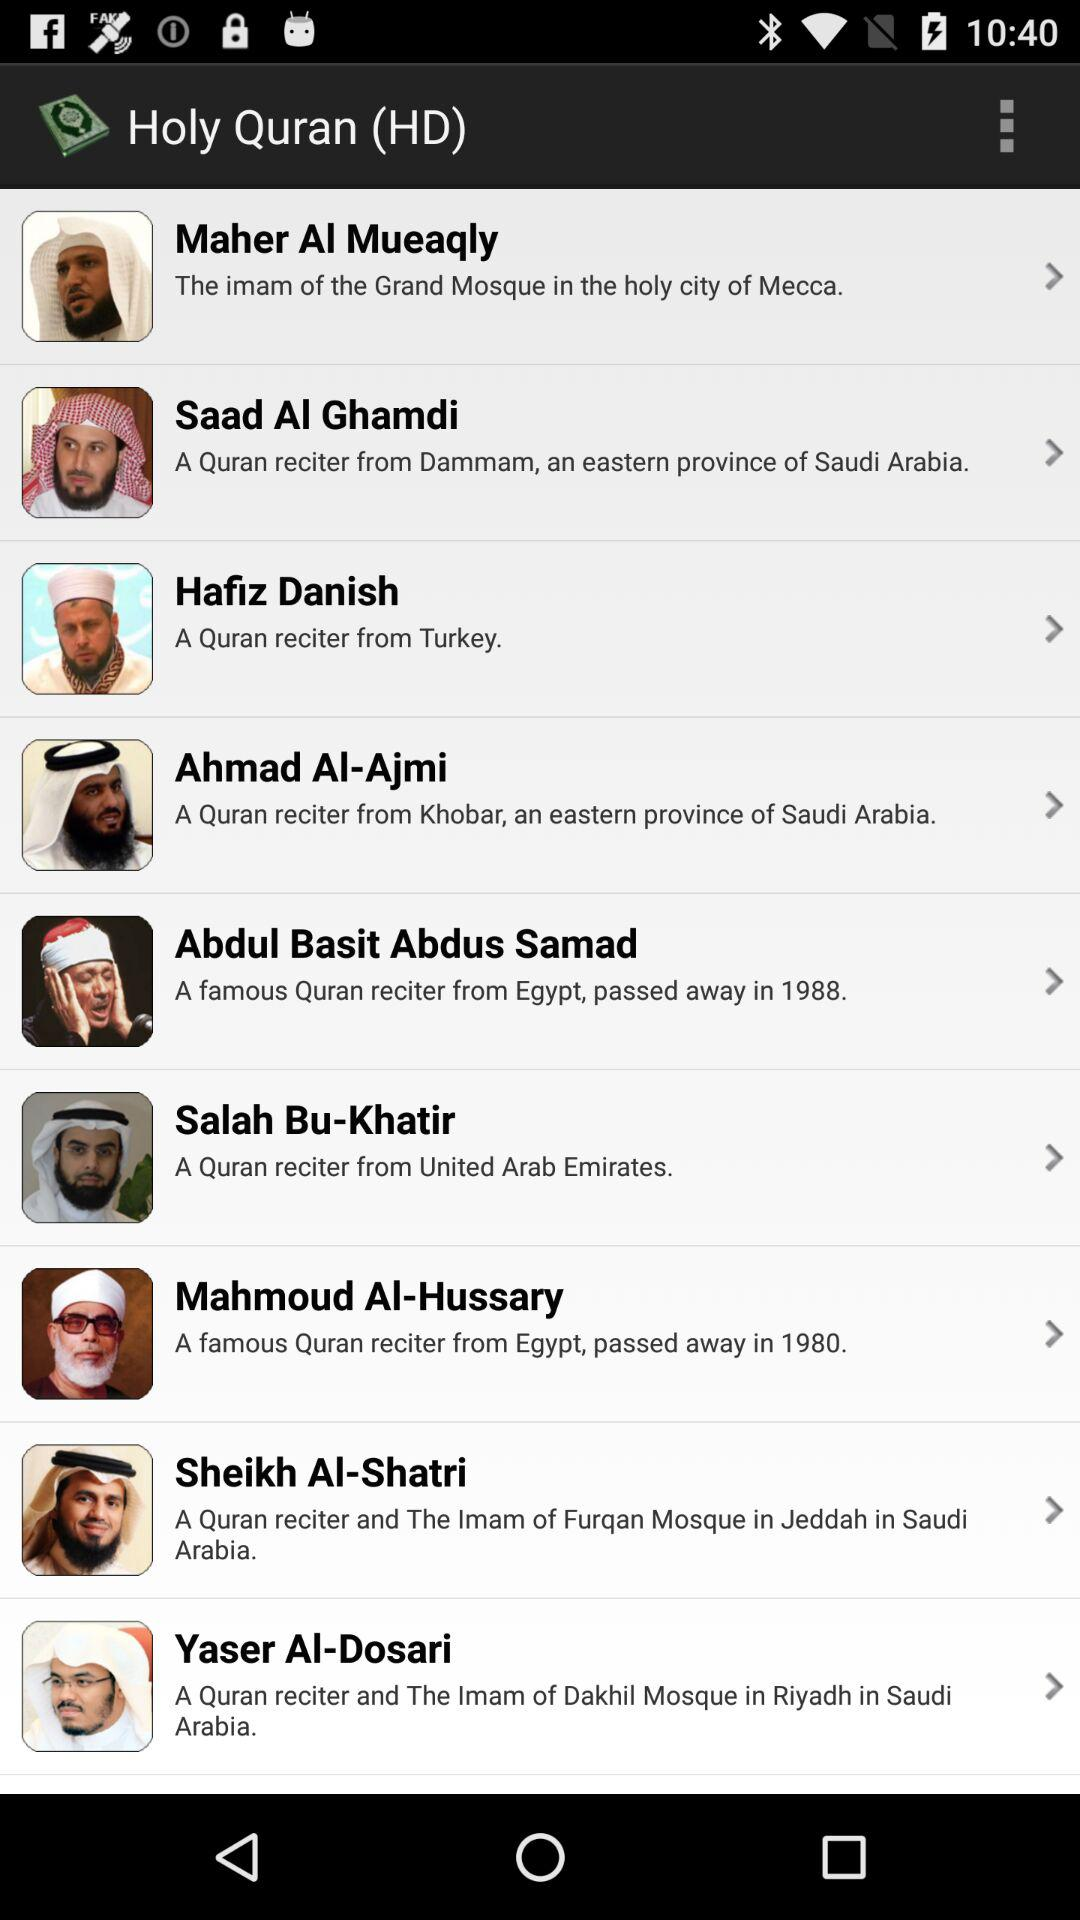How many reciters are from Egypt?
Answer the question using a single word or phrase. 2 